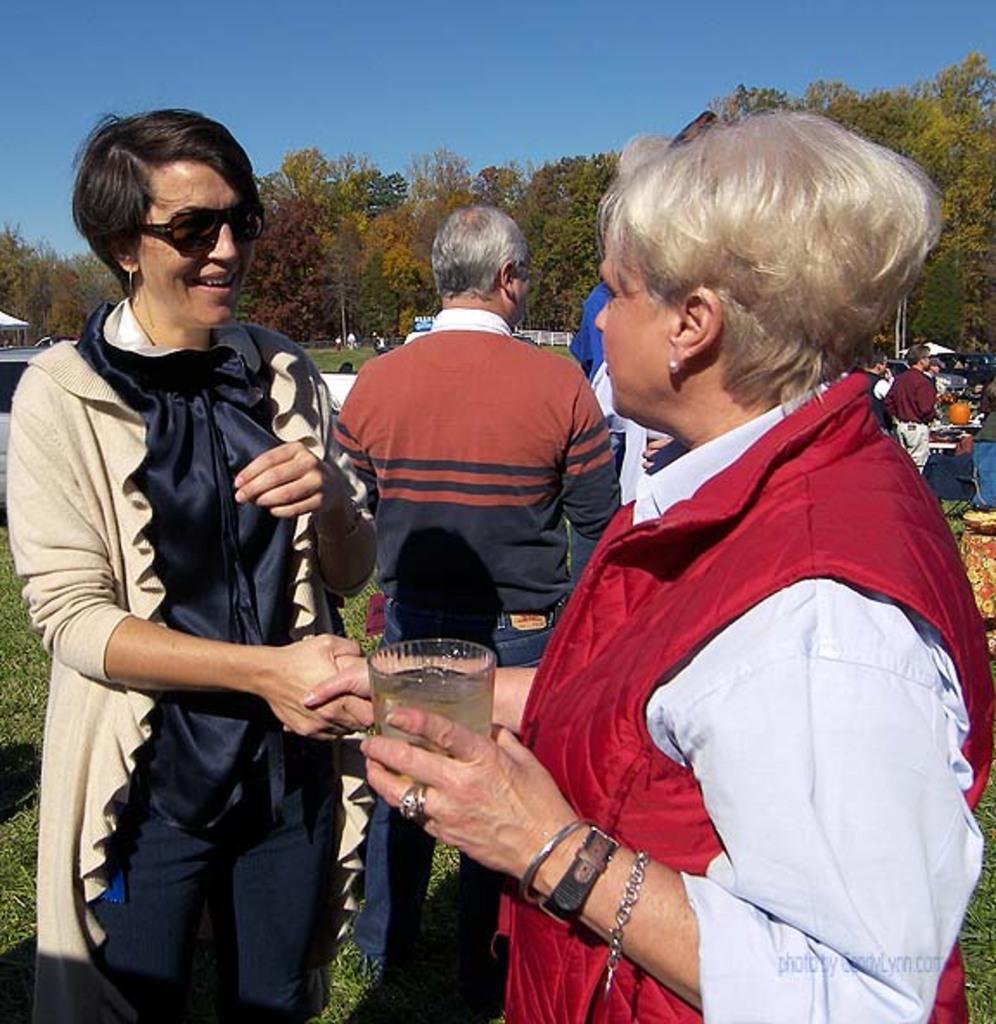Can you describe this image briefly? These three persons are standing and this man holding glass. Background we can see grass, persons, trees and sky. 